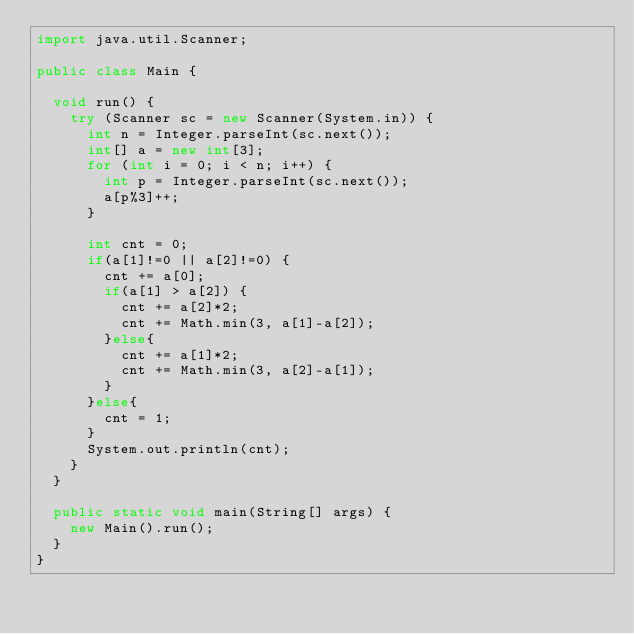<code> <loc_0><loc_0><loc_500><loc_500><_Java_>import java.util.Scanner;

public class Main {

	void run() {
		try (Scanner sc = new Scanner(System.in)) {
			int n = Integer.parseInt(sc.next());
			int[] a = new int[3];
			for (int i = 0; i < n; i++) {
				int p = Integer.parseInt(sc.next());
				a[p%3]++;
			}
			
			int cnt = 0;
			if(a[1]!=0 || a[2]!=0) {
				cnt += a[0];
				if(a[1] > a[2]) {
					cnt += a[2]*2;
					cnt += Math.min(3, a[1]-a[2]);
				}else{
					cnt += a[1]*2;
					cnt += Math.min(3, a[2]-a[1]);
				}
			}else{
				cnt = 1;
			}
			System.out.println(cnt);
		}
	}

	public static void main(String[] args) {
		new Main().run();
	}
}</code> 